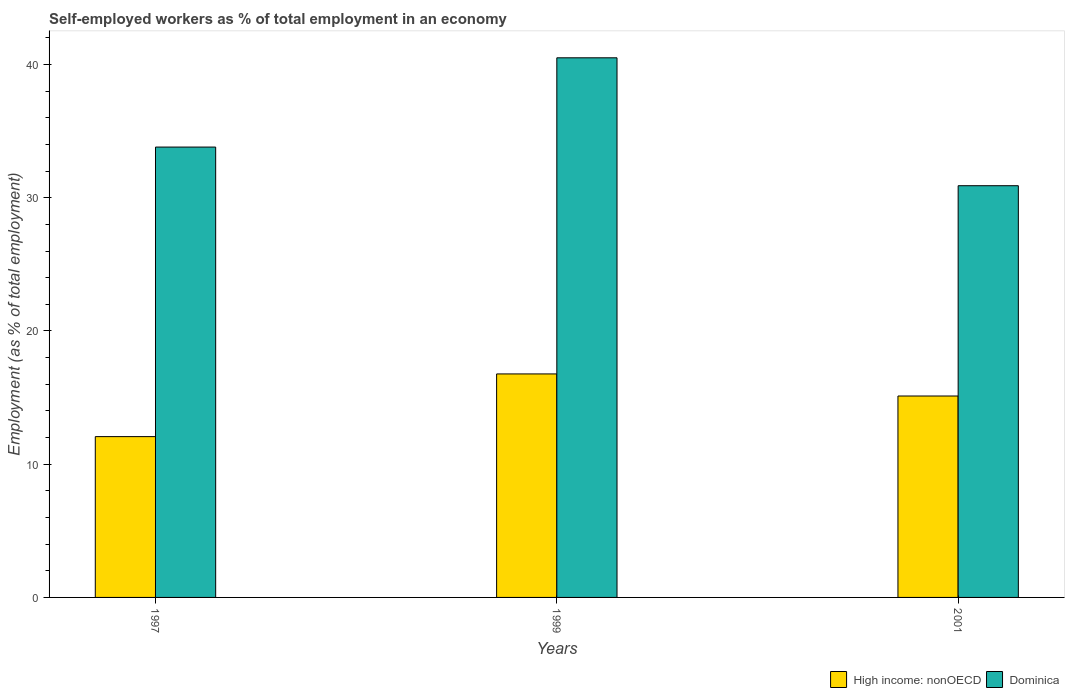Are the number of bars per tick equal to the number of legend labels?
Your response must be concise. Yes. How many bars are there on the 3rd tick from the left?
Make the answer very short. 2. How many bars are there on the 3rd tick from the right?
Offer a terse response. 2. In how many cases, is the number of bars for a given year not equal to the number of legend labels?
Your answer should be very brief. 0. What is the percentage of self-employed workers in Dominica in 2001?
Give a very brief answer. 30.9. Across all years, what is the maximum percentage of self-employed workers in High income: nonOECD?
Make the answer very short. 16.77. Across all years, what is the minimum percentage of self-employed workers in High income: nonOECD?
Provide a succinct answer. 12.07. In which year was the percentage of self-employed workers in High income: nonOECD minimum?
Provide a short and direct response. 1997. What is the total percentage of self-employed workers in Dominica in the graph?
Provide a succinct answer. 105.2. What is the difference between the percentage of self-employed workers in Dominica in 1999 and that in 2001?
Give a very brief answer. 9.6. What is the difference between the percentage of self-employed workers in High income: nonOECD in 2001 and the percentage of self-employed workers in Dominica in 1999?
Provide a succinct answer. -25.38. What is the average percentage of self-employed workers in High income: nonOECD per year?
Your answer should be compact. 14.65. In the year 1999, what is the difference between the percentage of self-employed workers in High income: nonOECD and percentage of self-employed workers in Dominica?
Your response must be concise. -23.73. In how many years, is the percentage of self-employed workers in High income: nonOECD greater than 30 %?
Your answer should be compact. 0. What is the ratio of the percentage of self-employed workers in High income: nonOECD in 1999 to that in 2001?
Keep it short and to the point. 1.11. What is the difference between the highest and the second highest percentage of self-employed workers in Dominica?
Provide a short and direct response. 6.7. What is the difference between the highest and the lowest percentage of self-employed workers in High income: nonOECD?
Provide a succinct answer. 4.7. What does the 1st bar from the left in 1997 represents?
Provide a short and direct response. High income: nonOECD. What does the 2nd bar from the right in 1997 represents?
Your answer should be very brief. High income: nonOECD. How many bars are there?
Provide a short and direct response. 6. Are all the bars in the graph horizontal?
Your answer should be very brief. No. How many years are there in the graph?
Ensure brevity in your answer.  3. Does the graph contain any zero values?
Provide a short and direct response. No. How many legend labels are there?
Keep it short and to the point. 2. What is the title of the graph?
Ensure brevity in your answer.  Self-employed workers as % of total employment in an economy. Does "Nicaragua" appear as one of the legend labels in the graph?
Offer a very short reply. No. What is the label or title of the Y-axis?
Your answer should be very brief. Employment (as % of total employment). What is the Employment (as % of total employment) of High income: nonOECD in 1997?
Offer a terse response. 12.07. What is the Employment (as % of total employment) in Dominica in 1997?
Make the answer very short. 33.8. What is the Employment (as % of total employment) in High income: nonOECD in 1999?
Make the answer very short. 16.77. What is the Employment (as % of total employment) of Dominica in 1999?
Your answer should be very brief. 40.5. What is the Employment (as % of total employment) in High income: nonOECD in 2001?
Ensure brevity in your answer.  15.12. What is the Employment (as % of total employment) in Dominica in 2001?
Offer a terse response. 30.9. Across all years, what is the maximum Employment (as % of total employment) of High income: nonOECD?
Provide a succinct answer. 16.77. Across all years, what is the maximum Employment (as % of total employment) of Dominica?
Provide a short and direct response. 40.5. Across all years, what is the minimum Employment (as % of total employment) of High income: nonOECD?
Your response must be concise. 12.07. Across all years, what is the minimum Employment (as % of total employment) in Dominica?
Ensure brevity in your answer.  30.9. What is the total Employment (as % of total employment) of High income: nonOECD in the graph?
Offer a terse response. 43.96. What is the total Employment (as % of total employment) in Dominica in the graph?
Offer a very short reply. 105.2. What is the difference between the Employment (as % of total employment) of High income: nonOECD in 1997 and that in 1999?
Give a very brief answer. -4.7. What is the difference between the Employment (as % of total employment) in High income: nonOECD in 1997 and that in 2001?
Your answer should be compact. -3.05. What is the difference between the Employment (as % of total employment) in High income: nonOECD in 1999 and that in 2001?
Your answer should be compact. 1.66. What is the difference between the Employment (as % of total employment) of Dominica in 1999 and that in 2001?
Offer a terse response. 9.6. What is the difference between the Employment (as % of total employment) of High income: nonOECD in 1997 and the Employment (as % of total employment) of Dominica in 1999?
Your answer should be compact. -28.43. What is the difference between the Employment (as % of total employment) in High income: nonOECD in 1997 and the Employment (as % of total employment) in Dominica in 2001?
Your response must be concise. -18.83. What is the difference between the Employment (as % of total employment) in High income: nonOECD in 1999 and the Employment (as % of total employment) in Dominica in 2001?
Provide a succinct answer. -14.13. What is the average Employment (as % of total employment) of High income: nonOECD per year?
Make the answer very short. 14.65. What is the average Employment (as % of total employment) in Dominica per year?
Give a very brief answer. 35.07. In the year 1997, what is the difference between the Employment (as % of total employment) in High income: nonOECD and Employment (as % of total employment) in Dominica?
Make the answer very short. -21.73. In the year 1999, what is the difference between the Employment (as % of total employment) in High income: nonOECD and Employment (as % of total employment) in Dominica?
Offer a very short reply. -23.73. In the year 2001, what is the difference between the Employment (as % of total employment) in High income: nonOECD and Employment (as % of total employment) in Dominica?
Make the answer very short. -15.78. What is the ratio of the Employment (as % of total employment) of High income: nonOECD in 1997 to that in 1999?
Your response must be concise. 0.72. What is the ratio of the Employment (as % of total employment) in Dominica in 1997 to that in 1999?
Your response must be concise. 0.83. What is the ratio of the Employment (as % of total employment) in High income: nonOECD in 1997 to that in 2001?
Keep it short and to the point. 0.8. What is the ratio of the Employment (as % of total employment) in Dominica in 1997 to that in 2001?
Provide a succinct answer. 1.09. What is the ratio of the Employment (as % of total employment) of High income: nonOECD in 1999 to that in 2001?
Your response must be concise. 1.11. What is the ratio of the Employment (as % of total employment) of Dominica in 1999 to that in 2001?
Your response must be concise. 1.31. What is the difference between the highest and the second highest Employment (as % of total employment) in High income: nonOECD?
Keep it short and to the point. 1.66. What is the difference between the highest and the lowest Employment (as % of total employment) in High income: nonOECD?
Your answer should be very brief. 4.7. What is the difference between the highest and the lowest Employment (as % of total employment) of Dominica?
Provide a succinct answer. 9.6. 